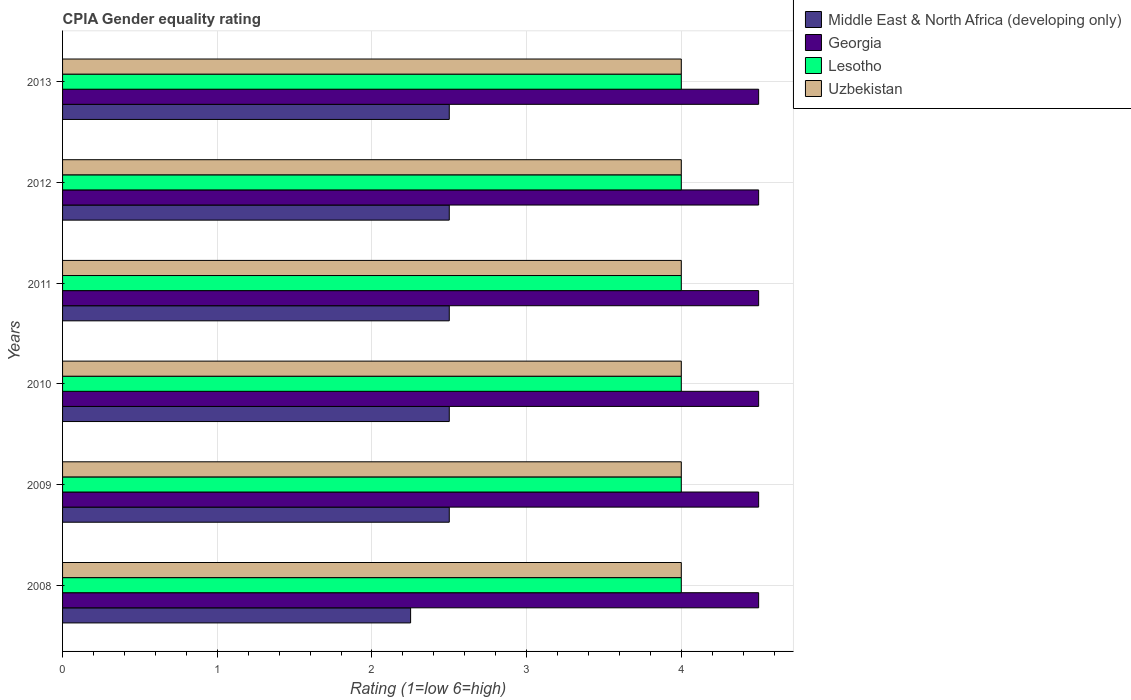How many groups of bars are there?
Ensure brevity in your answer.  6. Are the number of bars per tick equal to the number of legend labels?
Your answer should be compact. Yes. How many bars are there on the 1st tick from the top?
Keep it short and to the point. 4. How many bars are there on the 3rd tick from the bottom?
Ensure brevity in your answer.  4. In how many cases, is the number of bars for a given year not equal to the number of legend labels?
Give a very brief answer. 0. Across all years, what is the maximum CPIA rating in Lesotho?
Give a very brief answer. 4. Across all years, what is the minimum CPIA rating in Middle East & North Africa (developing only)?
Provide a short and direct response. 2.25. What is the total CPIA rating in Lesotho in the graph?
Your response must be concise. 24. What is the difference between the CPIA rating in Uzbekistan in 2009 and that in 2010?
Provide a succinct answer. 0. What is the difference between the CPIA rating in Uzbekistan in 2013 and the CPIA rating in Georgia in 2012?
Make the answer very short. -0.5. What is the average CPIA rating in Georgia per year?
Your answer should be very brief. 4.5. In the year 2009, what is the difference between the CPIA rating in Middle East & North Africa (developing only) and CPIA rating in Georgia?
Provide a short and direct response. -2. In how many years, is the CPIA rating in Georgia greater than 1.4 ?
Your answer should be compact. 6. What is the difference between the highest and the lowest CPIA rating in Middle East & North Africa (developing only)?
Provide a succinct answer. 0.25. In how many years, is the CPIA rating in Middle East & North Africa (developing only) greater than the average CPIA rating in Middle East & North Africa (developing only) taken over all years?
Offer a very short reply. 5. Is the sum of the CPIA rating in Uzbekistan in 2008 and 2012 greater than the maximum CPIA rating in Lesotho across all years?
Your response must be concise. Yes. What does the 2nd bar from the top in 2008 represents?
Offer a very short reply. Lesotho. What does the 3rd bar from the bottom in 2011 represents?
Offer a terse response. Lesotho. How many bars are there?
Your answer should be compact. 24. What is the difference between two consecutive major ticks on the X-axis?
Ensure brevity in your answer.  1. Are the values on the major ticks of X-axis written in scientific E-notation?
Offer a terse response. No. Does the graph contain any zero values?
Make the answer very short. No. Where does the legend appear in the graph?
Keep it short and to the point. Top right. How many legend labels are there?
Make the answer very short. 4. What is the title of the graph?
Provide a succinct answer. CPIA Gender equality rating. Does "Monaco" appear as one of the legend labels in the graph?
Your answer should be compact. No. What is the label or title of the Y-axis?
Make the answer very short. Years. What is the Rating (1=low 6=high) of Middle East & North Africa (developing only) in 2008?
Offer a very short reply. 2.25. What is the Rating (1=low 6=high) in Lesotho in 2008?
Provide a succinct answer. 4. What is the Rating (1=low 6=high) in Uzbekistan in 2008?
Make the answer very short. 4. What is the Rating (1=low 6=high) of Middle East & North Africa (developing only) in 2009?
Offer a terse response. 2.5. What is the Rating (1=low 6=high) in Lesotho in 2009?
Keep it short and to the point. 4. What is the Rating (1=low 6=high) of Uzbekistan in 2009?
Ensure brevity in your answer.  4. What is the Rating (1=low 6=high) in Lesotho in 2010?
Ensure brevity in your answer.  4. What is the Rating (1=low 6=high) in Uzbekistan in 2010?
Offer a terse response. 4. What is the Rating (1=low 6=high) of Georgia in 2011?
Your response must be concise. 4.5. What is the Rating (1=low 6=high) of Georgia in 2012?
Give a very brief answer. 4.5. What is the Rating (1=low 6=high) in Georgia in 2013?
Give a very brief answer. 4.5. Across all years, what is the maximum Rating (1=low 6=high) in Middle East & North Africa (developing only)?
Offer a very short reply. 2.5. Across all years, what is the maximum Rating (1=low 6=high) in Georgia?
Provide a short and direct response. 4.5. Across all years, what is the maximum Rating (1=low 6=high) in Uzbekistan?
Your answer should be compact. 4. Across all years, what is the minimum Rating (1=low 6=high) of Middle East & North Africa (developing only)?
Offer a very short reply. 2.25. Across all years, what is the minimum Rating (1=low 6=high) of Lesotho?
Provide a succinct answer. 4. Across all years, what is the minimum Rating (1=low 6=high) of Uzbekistan?
Provide a short and direct response. 4. What is the total Rating (1=low 6=high) in Middle East & North Africa (developing only) in the graph?
Make the answer very short. 14.75. What is the total Rating (1=low 6=high) in Uzbekistan in the graph?
Keep it short and to the point. 24. What is the difference between the Rating (1=low 6=high) of Georgia in 2008 and that in 2009?
Your answer should be compact. 0. What is the difference between the Rating (1=low 6=high) in Middle East & North Africa (developing only) in 2008 and that in 2010?
Provide a short and direct response. -0.25. What is the difference between the Rating (1=low 6=high) of Georgia in 2008 and that in 2010?
Your response must be concise. 0. What is the difference between the Rating (1=low 6=high) of Lesotho in 2008 and that in 2010?
Offer a very short reply. 0. What is the difference between the Rating (1=low 6=high) of Uzbekistan in 2008 and that in 2010?
Offer a very short reply. 0. What is the difference between the Rating (1=low 6=high) of Uzbekistan in 2008 and that in 2011?
Keep it short and to the point. 0. What is the difference between the Rating (1=low 6=high) of Middle East & North Africa (developing only) in 2008 and that in 2012?
Make the answer very short. -0.25. What is the difference between the Rating (1=low 6=high) of Uzbekistan in 2008 and that in 2012?
Make the answer very short. 0. What is the difference between the Rating (1=low 6=high) in Lesotho in 2008 and that in 2013?
Make the answer very short. 0. What is the difference between the Rating (1=low 6=high) of Uzbekistan in 2008 and that in 2013?
Keep it short and to the point. 0. What is the difference between the Rating (1=low 6=high) of Middle East & North Africa (developing only) in 2009 and that in 2010?
Your response must be concise. 0. What is the difference between the Rating (1=low 6=high) of Lesotho in 2009 and that in 2010?
Keep it short and to the point. 0. What is the difference between the Rating (1=low 6=high) in Uzbekistan in 2009 and that in 2010?
Keep it short and to the point. 0. What is the difference between the Rating (1=low 6=high) in Middle East & North Africa (developing only) in 2009 and that in 2011?
Your answer should be very brief. 0. What is the difference between the Rating (1=low 6=high) in Georgia in 2009 and that in 2011?
Make the answer very short. 0. What is the difference between the Rating (1=low 6=high) of Georgia in 2009 and that in 2012?
Offer a terse response. 0. What is the difference between the Rating (1=low 6=high) of Middle East & North Africa (developing only) in 2009 and that in 2013?
Ensure brevity in your answer.  0. What is the difference between the Rating (1=low 6=high) of Georgia in 2009 and that in 2013?
Your response must be concise. 0. What is the difference between the Rating (1=low 6=high) in Lesotho in 2009 and that in 2013?
Ensure brevity in your answer.  0. What is the difference between the Rating (1=low 6=high) in Lesotho in 2010 and that in 2011?
Ensure brevity in your answer.  0. What is the difference between the Rating (1=low 6=high) in Middle East & North Africa (developing only) in 2010 and that in 2012?
Provide a succinct answer. 0. What is the difference between the Rating (1=low 6=high) in Middle East & North Africa (developing only) in 2010 and that in 2013?
Offer a terse response. 0. What is the difference between the Rating (1=low 6=high) in Lesotho in 2010 and that in 2013?
Offer a very short reply. 0. What is the difference between the Rating (1=low 6=high) of Uzbekistan in 2010 and that in 2013?
Provide a short and direct response. 0. What is the difference between the Rating (1=low 6=high) in Lesotho in 2011 and that in 2012?
Give a very brief answer. 0. What is the difference between the Rating (1=low 6=high) of Middle East & North Africa (developing only) in 2011 and that in 2013?
Your answer should be compact. 0. What is the difference between the Rating (1=low 6=high) of Lesotho in 2011 and that in 2013?
Offer a terse response. 0. What is the difference between the Rating (1=low 6=high) of Uzbekistan in 2011 and that in 2013?
Ensure brevity in your answer.  0. What is the difference between the Rating (1=low 6=high) in Uzbekistan in 2012 and that in 2013?
Make the answer very short. 0. What is the difference between the Rating (1=low 6=high) in Middle East & North Africa (developing only) in 2008 and the Rating (1=low 6=high) in Georgia in 2009?
Your answer should be very brief. -2.25. What is the difference between the Rating (1=low 6=high) of Middle East & North Africa (developing only) in 2008 and the Rating (1=low 6=high) of Lesotho in 2009?
Your answer should be very brief. -1.75. What is the difference between the Rating (1=low 6=high) in Middle East & North Africa (developing only) in 2008 and the Rating (1=low 6=high) in Uzbekistan in 2009?
Ensure brevity in your answer.  -1.75. What is the difference between the Rating (1=low 6=high) in Georgia in 2008 and the Rating (1=low 6=high) in Uzbekistan in 2009?
Offer a terse response. 0.5. What is the difference between the Rating (1=low 6=high) of Lesotho in 2008 and the Rating (1=low 6=high) of Uzbekistan in 2009?
Your answer should be very brief. 0. What is the difference between the Rating (1=low 6=high) of Middle East & North Africa (developing only) in 2008 and the Rating (1=low 6=high) of Georgia in 2010?
Ensure brevity in your answer.  -2.25. What is the difference between the Rating (1=low 6=high) in Middle East & North Africa (developing only) in 2008 and the Rating (1=low 6=high) in Lesotho in 2010?
Ensure brevity in your answer.  -1.75. What is the difference between the Rating (1=low 6=high) in Middle East & North Africa (developing only) in 2008 and the Rating (1=low 6=high) in Uzbekistan in 2010?
Offer a terse response. -1.75. What is the difference between the Rating (1=low 6=high) of Georgia in 2008 and the Rating (1=low 6=high) of Lesotho in 2010?
Make the answer very short. 0.5. What is the difference between the Rating (1=low 6=high) of Middle East & North Africa (developing only) in 2008 and the Rating (1=low 6=high) of Georgia in 2011?
Your answer should be compact. -2.25. What is the difference between the Rating (1=low 6=high) of Middle East & North Africa (developing only) in 2008 and the Rating (1=low 6=high) of Lesotho in 2011?
Offer a terse response. -1.75. What is the difference between the Rating (1=low 6=high) in Middle East & North Africa (developing only) in 2008 and the Rating (1=low 6=high) in Uzbekistan in 2011?
Make the answer very short. -1.75. What is the difference between the Rating (1=low 6=high) of Georgia in 2008 and the Rating (1=low 6=high) of Lesotho in 2011?
Provide a succinct answer. 0.5. What is the difference between the Rating (1=low 6=high) in Middle East & North Africa (developing only) in 2008 and the Rating (1=low 6=high) in Georgia in 2012?
Keep it short and to the point. -2.25. What is the difference between the Rating (1=low 6=high) of Middle East & North Africa (developing only) in 2008 and the Rating (1=low 6=high) of Lesotho in 2012?
Your answer should be very brief. -1.75. What is the difference between the Rating (1=low 6=high) in Middle East & North Africa (developing only) in 2008 and the Rating (1=low 6=high) in Uzbekistan in 2012?
Your answer should be compact. -1.75. What is the difference between the Rating (1=low 6=high) of Georgia in 2008 and the Rating (1=low 6=high) of Lesotho in 2012?
Keep it short and to the point. 0.5. What is the difference between the Rating (1=low 6=high) of Georgia in 2008 and the Rating (1=low 6=high) of Uzbekistan in 2012?
Offer a very short reply. 0.5. What is the difference between the Rating (1=low 6=high) in Middle East & North Africa (developing only) in 2008 and the Rating (1=low 6=high) in Georgia in 2013?
Ensure brevity in your answer.  -2.25. What is the difference between the Rating (1=low 6=high) of Middle East & North Africa (developing only) in 2008 and the Rating (1=low 6=high) of Lesotho in 2013?
Ensure brevity in your answer.  -1.75. What is the difference between the Rating (1=low 6=high) in Middle East & North Africa (developing only) in 2008 and the Rating (1=low 6=high) in Uzbekistan in 2013?
Provide a succinct answer. -1.75. What is the difference between the Rating (1=low 6=high) in Georgia in 2008 and the Rating (1=low 6=high) in Lesotho in 2013?
Offer a terse response. 0.5. What is the difference between the Rating (1=low 6=high) in Lesotho in 2008 and the Rating (1=low 6=high) in Uzbekistan in 2013?
Ensure brevity in your answer.  0. What is the difference between the Rating (1=low 6=high) in Middle East & North Africa (developing only) in 2009 and the Rating (1=low 6=high) in Lesotho in 2010?
Your answer should be compact. -1.5. What is the difference between the Rating (1=low 6=high) of Georgia in 2009 and the Rating (1=low 6=high) of Lesotho in 2010?
Your answer should be very brief. 0.5. What is the difference between the Rating (1=low 6=high) in Georgia in 2009 and the Rating (1=low 6=high) in Uzbekistan in 2010?
Offer a very short reply. 0.5. What is the difference between the Rating (1=low 6=high) of Georgia in 2009 and the Rating (1=low 6=high) of Lesotho in 2011?
Ensure brevity in your answer.  0.5. What is the difference between the Rating (1=low 6=high) in Georgia in 2009 and the Rating (1=low 6=high) in Uzbekistan in 2011?
Offer a terse response. 0.5. What is the difference between the Rating (1=low 6=high) of Lesotho in 2009 and the Rating (1=low 6=high) of Uzbekistan in 2011?
Offer a very short reply. 0. What is the difference between the Rating (1=low 6=high) of Middle East & North Africa (developing only) in 2009 and the Rating (1=low 6=high) of Georgia in 2012?
Your response must be concise. -2. What is the difference between the Rating (1=low 6=high) of Middle East & North Africa (developing only) in 2009 and the Rating (1=low 6=high) of Lesotho in 2012?
Make the answer very short. -1.5. What is the difference between the Rating (1=low 6=high) in Middle East & North Africa (developing only) in 2009 and the Rating (1=low 6=high) in Uzbekistan in 2012?
Your response must be concise. -1.5. What is the difference between the Rating (1=low 6=high) in Georgia in 2009 and the Rating (1=low 6=high) in Uzbekistan in 2012?
Offer a terse response. 0.5. What is the difference between the Rating (1=low 6=high) in Lesotho in 2009 and the Rating (1=low 6=high) in Uzbekistan in 2012?
Ensure brevity in your answer.  0. What is the difference between the Rating (1=low 6=high) in Middle East & North Africa (developing only) in 2009 and the Rating (1=low 6=high) in Georgia in 2013?
Offer a terse response. -2. What is the difference between the Rating (1=low 6=high) of Georgia in 2009 and the Rating (1=low 6=high) of Lesotho in 2013?
Keep it short and to the point. 0.5. What is the difference between the Rating (1=low 6=high) in Georgia in 2009 and the Rating (1=low 6=high) in Uzbekistan in 2013?
Your response must be concise. 0.5. What is the difference between the Rating (1=low 6=high) of Middle East & North Africa (developing only) in 2010 and the Rating (1=low 6=high) of Lesotho in 2011?
Offer a terse response. -1.5. What is the difference between the Rating (1=low 6=high) in Middle East & North Africa (developing only) in 2010 and the Rating (1=low 6=high) in Uzbekistan in 2011?
Provide a short and direct response. -1.5. What is the difference between the Rating (1=low 6=high) of Lesotho in 2010 and the Rating (1=low 6=high) of Uzbekistan in 2011?
Your answer should be compact. 0. What is the difference between the Rating (1=low 6=high) of Middle East & North Africa (developing only) in 2010 and the Rating (1=low 6=high) of Lesotho in 2012?
Offer a very short reply. -1.5. What is the difference between the Rating (1=low 6=high) of Lesotho in 2010 and the Rating (1=low 6=high) of Uzbekistan in 2012?
Your answer should be compact. 0. What is the difference between the Rating (1=low 6=high) in Middle East & North Africa (developing only) in 2010 and the Rating (1=low 6=high) in Lesotho in 2013?
Provide a succinct answer. -1.5. What is the difference between the Rating (1=low 6=high) of Georgia in 2010 and the Rating (1=low 6=high) of Uzbekistan in 2013?
Offer a terse response. 0.5. What is the difference between the Rating (1=low 6=high) of Lesotho in 2010 and the Rating (1=low 6=high) of Uzbekistan in 2013?
Give a very brief answer. 0. What is the difference between the Rating (1=low 6=high) of Middle East & North Africa (developing only) in 2011 and the Rating (1=low 6=high) of Lesotho in 2012?
Provide a short and direct response. -1.5. What is the difference between the Rating (1=low 6=high) in Middle East & North Africa (developing only) in 2011 and the Rating (1=low 6=high) in Uzbekistan in 2012?
Your response must be concise. -1.5. What is the difference between the Rating (1=low 6=high) in Georgia in 2011 and the Rating (1=low 6=high) in Lesotho in 2012?
Your answer should be very brief. 0.5. What is the difference between the Rating (1=low 6=high) in Lesotho in 2011 and the Rating (1=low 6=high) in Uzbekistan in 2012?
Offer a terse response. 0. What is the difference between the Rating (1=low 6=high) of Middle East & North Africa (developing only) in 2011 and the Rating (1=low 6=high) of Georgia in 2013?
Offer a terse response. -2. What is the difference between the Rating (1=low 6=high) in Middle East & North Africa (developing only) in 2011 and the Rating (1=low 6=high) in Lesotho in 2013?
Provide a succinct answer. -1.5. What is the difference between the Rating (1=low 6=high) in Middle East & North Africa (developing only) in 2012 and the Rating (1=low 6=high) in Georgia in 2013?
Make the answer very short. -2. What is the difference between the Rating (1=low 6=high) in Middle East & North Africa (developing only) in 2012 and the Rating (1=low 6=high) in Lesotho in 2013?
Give a very brief answer. -1.5. What is the difference between the Rating (1=low 6=high) of Georgia in 2012 and the Rating (1=low 6=high) of Lesotho in 2013?
Ensure brevity in your answer.  0.5. What is the average Rating (1=low 6=high) in Middle East & North Africa (developing only) per year?
Keep it short and to the point. 2.46. What is the average Rating (1=low 6=high) of Lesotho per year?
Give a very brief answer. 4. In the year 2008, what is the difference between the Rating (1=low 6=high) in Middle East & North Africa (developing only) and Rating (1=low 6=high) in Georgia?
Make the answer very short. -2.25. In the year 2008, what is the difference between the Rating (1=low 6=high) of Middle East & North Africa (developing only) and Rating (1=low 6=high) of Lesotho?
Make the answer very short. -1.75. In the year 2008, what is the difference between the Rating (1=low 6=high) of Middle East & North Africa (developing only) and Rating (1=low 6=high) of Uzbekistan?
Give a very brief answer. -1.75. In the year 2009, what is the difference between the Rating (1=low 6=high) of Middle East & North Africa (developing only) and Rating (1=low 6=high) of Georgia?
Provide a succinct answer. -2. In the year 2009, what is the difference between the Rating (1=low 6=high) of Middle East & North Africa (developing only) and Rating (1=low 6=high) of Lesotho?
Your response must be concise. -1.5. In the year 2009, what is the difference between the Rating (1=low 6=high) in Georgia and Rating (1=low 6=high) in Lesotho?
Offer a terse response. 0.5. In the year 2010, what is the difference between the Rating (1=low 6=high) in Middle East & North Africa (developing only) and Rating (1=low 6=high) in Lesotho?
Keep it short and to the point. -1.5. In the year 2010, what is the difference between the Rating (1=low 6=high) in Middle East & North Africa (developing only) and Rating (1=low 6=high) in Uzbekistan?
Make the answer very short. -1.5. In the year 2010, what is the difference between the Rating (1=low 6=high) of Georgia and Rating (1=low 6=high) of Lesotho?
Offer a terse response. 0.5. In the year 2010, what is the difference between the Rating (1=low 6=high) in Georgia and Rating (1=low 6=high) in Uzbekistan?
Offer a terse response. 0.5. In the year 2010, what is the difference between the Rating (1=low 6=high) in Lesotho and Rating (1=low 6=high) in Uzbekistan?
Ensure brevity in your answer.  0. In the year 2011, what is the difference between the Rating (1=low 6=high) of Middle East & North Africa (developing only) and Rating (1=low 6=high) of Georgia?
Offer a terse response. -2. In the year 2011, what is the difference between the Rating (1=low 6=high) of Middle East & North Africa (developing only) and Rating (1=low 6=high) of Lesotho?
Your answer should be compact. -1.5. In the year 2011, what is the difference between the Rating (1=low 6=high) of Middle East & North Africa (developing only) and Rating (1=low 6=high) of Uzbekistan?
Provide a succinct answer. -1.5. In the year 2011, what is the difference between the Rating (1=low 6=high) in Georgia and Rating (1=low 6=high) in Lesotho?
Offer a very short reply. 0.5. In the year 2011, what is the difference between the Rating (1=low 6=high) in Georgia and Rating (1=low 6=high) in Uzbekistan?
Your answer should be very brief. 0.5. In the year 2012, what is the difference between the Rating (1=low 6=high) in Georgia and Rating (1=low 6=high) in Lesotho?
Offer a terse response. 0.5. In the year 2013, what is the difference between the Rating (1=low 6=high) of Middle East & North Africa (developing only) and Rating (1=low 6=high) of Lesotho?
Ensure brevity in your answer.  -1.5. In the year 2013, what is the difference between the Rating (1=low 6=high) of Middle East & North Africa (developing only) and Rating (1=low 6=high) of Uzbekistan?
Offer a very short reply. -1.5. In the year 2013, what is the difference between the Rating (1=low 6=high) in Georgia and Rating (1=low 6=high) in Uzbekistan?
Provide a short and direct response. 0.5. In the year 2013, what is the difference between the Rating (1=low 6=high) of Lesotho and Rating (1=low 6=high) of Uzbekistan?
Ensure brevity in your answer.  0. What is the ratio of the Rating (1=low 6=high) in Middle East & North Africa (developing only) in 2008 to that in 2009?
Your answer should be compact. 0.9. What is the ratio of the Rating (1=low 6=high) in Georgia in 2008 to that in 2009?
Provide a short and direct response. 1. What is the ratio of the Rating (1=low 6=high) in Lesotho in 2008 to that in 2009?
Keep it short and to the point. 1. What is the ratio of the Rating (1=low 6=high) in Middle East & North Africa (developing only) in 2008 to that in 2011?
Offer a terse response. 0.9. What is the ratio of the Rating (1=low 6=high) of Middle East & North Africa (developing only) in 2008 to that in 2013?
Give a very brief answer. 0.9. What is the ratio of the Rating (1=low 6=high) of Georgia in 2008 to that in 2013?
Offer a very short reply. 1. What is the ratio of the Rating (1=low 6=high) of Uzbekistan in 2008 to that in 2013?
Your response must be concise. 1. What is the ratio of the Rating (1=low 6=high) of Georgia in 2009 to that in 2010?
Offer a very short reply. 1. What is the ratio of the Rating (1=low 6=high) of Uzbekistan in 2009 to that in 2010?
Your answer should be very brief. 1. What is the ratio of the Rating (1=low 6=high) in Middle East & North Africa (developing only) in 2009 to that in 2011?
Make the answer very short. 1. What is the ratio of the Rating (1=low 6=high) of Lesotho in 2009 to that in 2012?
Give a very brief answer. 1. What is the ratio of the Rating (1=low 6=high) of Middle East & North Africa (developing only) in 2009 to that in 2013?
Your answer should be very brief. 1. What is the ratio of the Rating (1=low 6=high) of Lesotho in 2009 to that in 2013?
Give a very brief answer. 1. What is the ratio of the Rating (1=low 6=high) in Uzbekistan in 2010 to that in 2011?
Provide a succinct answer. 1. What is the ratio of the Rating (1=low 6=high) in Georgia in 2010 to that in 2012?
Your response must be concise. 1. What is the ratio of the Rating (1=low 6=high) in Middle East & North Africa (developing only) in 2010 to that in 2013?
Keep it short and to the point. 1. What is the ratio of the Rating (1=low 6=high) of Georgia in 2010 to that in 2013?
Ensure brevity in your answer.  1. What is the ratio of the Rating (1=low 6=high) of Uzbekistan in 2010 to that in 2013?
Your answer should be very brief. 1. What is the ratio of the Rating (1=low 6=high) in Middle East & North Africa (developing only) in 2011 to that in 2012?
Give a very brief answer. 1. What is the ratio of the Rating (1=low 6=high) of Lesotho in 2011 to that in 2012?
Offer a very short reply. 1. What is the ratio of the Rating (1=low 6=high) of Middle East & North Africa (developing only) in 2011 to that in 2013?
Your answer should be very brief. 1. What is the ratio of the Rating (1=low 6=high) of Middle East & North Africa (developing only) in 2012 to that in 2013?
Your answer should be compact. 1. What is the ratio of the Rating (1=low 6=high) in Uzbekistan in 2012 to that in 2013?
Offer a very short reply. 1. What is the difference between the highest and the second highest Rating (1=low 6=high) in Middle East & North Africa (developing only)?
Provide a succinct answer. 0. What is the difference between the highest and the second highest Rating (1=low 6=high) of Georgia?
Your answer should be compact. 0. What is the difference between the highest and the lowest Rating (1=low 6=high) of Middle East & North Africa (developing only)?
Provide a succinct answer. 0.25. What is the difference between the highest and the lowest Rating (1=low 6=high) in Georgia?
Offer a very short reply. 0. What is the difference between the highest and the lowest Rating (1=low 6=high) of Uzbekistan?
Your answer should be very brief. 0. 